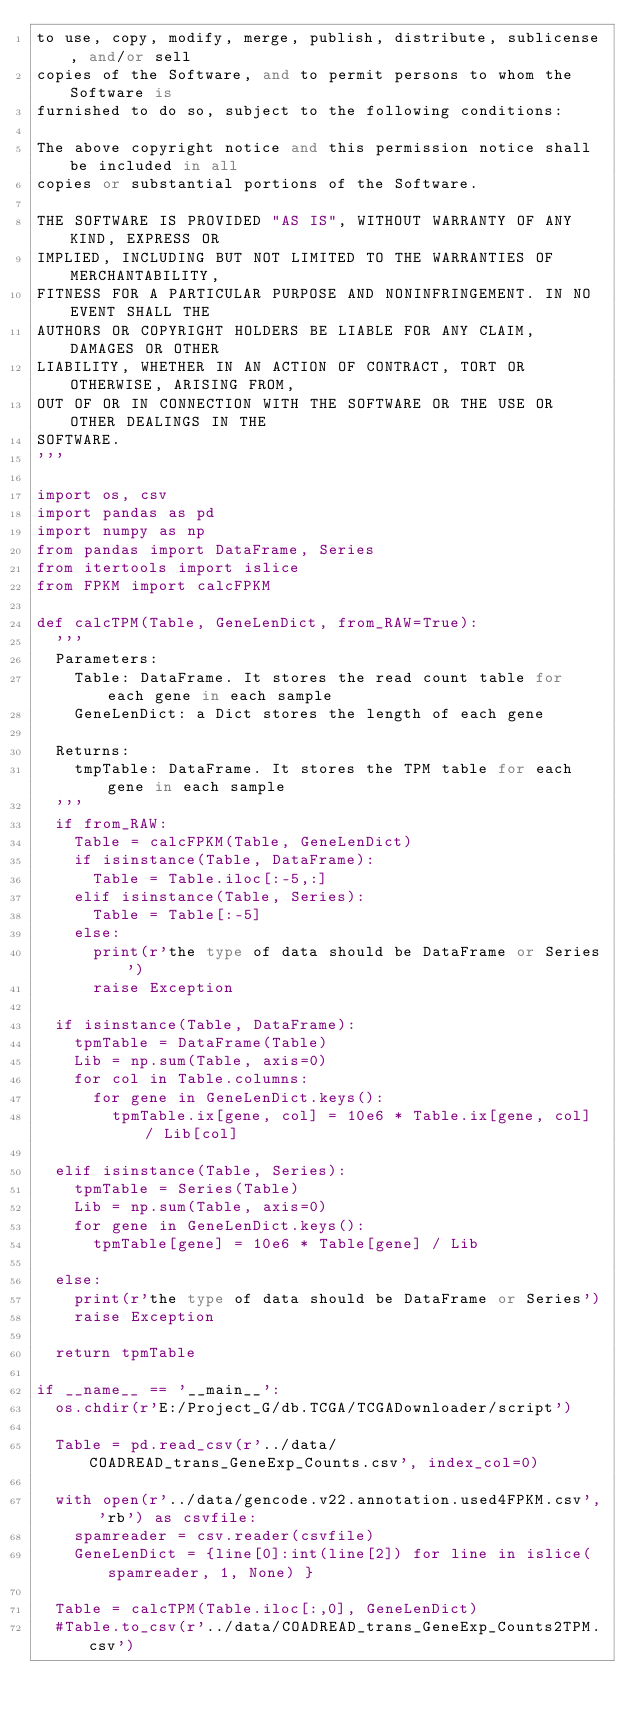Convert code to text. <code><loc_0><loc_0><loc_500><loc_500><_Python_>to use, copy, modify, merge, publish, distribute, sublicense, and/or sell
copies of the Software, and to permit persons to whom the Software is
furnished to do so, subject to the following conditions:

The above copyright notice and this permission notice shall be included in all
copies or substantial portions of the Software.

THE SOFTWARE IS PROVIDED "AS IS", WITHOUT WARRANTY OF ANY KIND, EXPRESS OR
IMPLIED, INCLUDING BUT NOT LIMITED TO THE WARRANTIES OF MERCHANTABILITY,
FITNESS FOR A PARTICULAR PURPOSE AND NONINFRINGEMENT. IN NO EVENT SHALL THE
AUTHORS OR COPYRIGHT HOLDERS BE LIABLE FOR ANY CLAIM, DAMAGES OR OTHER
LIABILITY, WHETHER IN AN ACTION OF CONTRACT, TORT OR OTHERWISE, ARISING FROM,
OUT OF OR IN CONNECTION WITH THE SOFTWARE OR THE USE OR OTHER DEALINGS IN THE
SOFTWARE.
'''

import os, csv
import pandas as pd
import numpy as np
from pandas import DataFrame, Series
from itertools import islice
from FPKM import calcFPKM

def calcTPM(Table, GeneLenDict, from_RAW=True):
	'''
	Parameters:
		Table: DataFrame. It stores the read count table for each gene in each sample
		GeneLenDict: a Dict stores the length of each gene
		
	Returns:
		tmpTable: DataFrame. It stores the TPM table for each gene in each sample
	'''
	if from_RAW:
		Table = calcFPKM(Table, GeneLenDict)
		if isinstance(Table, DataFrame):
			Table = Table.iloc[:-5,:]
		elif isinstance(Table, Series):
			Table = Table[:-5]
		else:
			print(r'the type of data should be DataFrame or Series')
			raise Exception

	if isinstance(Table, DataFrame):
		tpmTable = DataFrame(Table)
		Lib = np.sum(Table, axis=0)
		for col in Table.columns:
			for gene in GeneLenDict.keys():
				tpmTable.ix[gene, col] = 10e6 * Table.ix[gene, col] / Lib[col]
				
	elif isinstance(Table, Series):
		tpmTable = Series(Table)
		Lib = np.sum(Table, axis=0)
		for gene in GeneLenDict.keys():
			tpmTable[gene] = 10e6 * Table[gene] / Lib
	
	else:
		print(r'the type of data should be DataFrame or Series')
		raise Exception
			
	return tpmTable
	
if __name__ == '__main__':
	os.chdir(r'E:/Project_G/db.TCGA/TCGADownloader/script')
	
	Table = pd.read_csv(r'../data/COADREAD_trans_GeneExp_Counts.csv', index_col=0)
	
	with open(r'../data/gencode.v22.annotation.used4FPKM.csv', 'rb') as csvfile:
		spamreader = csv.reader(csvfile)
		GeneLenDict = {line[0]:int(line[2]) for line in islice(spamreader, 1, None) }
		
	Table = calcTPM(Table.iloc[:,0], GeneLenDict)
	#Table.to_csv(r'../data/COADREAD_trans_GeneExp_Counts2TPM.csv')
	
	</code> 